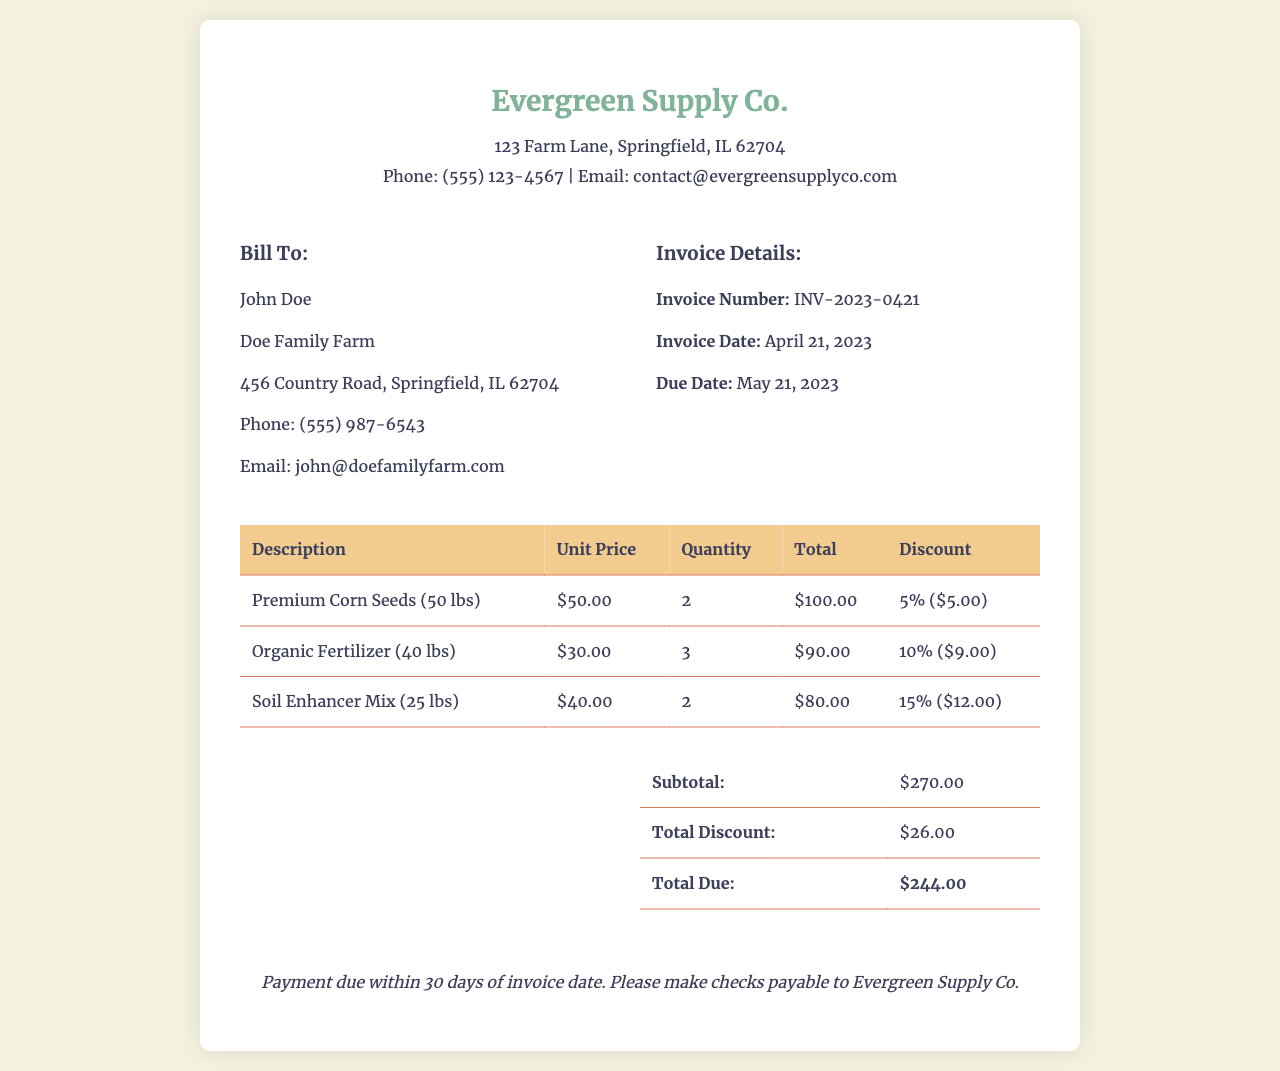What is the invoice number? The invoice number is clearly stated in the document under "Invoice Details."
Answer: INV-2023-0421 What is the total due amount? The total due amount is summarized in the final section of the invoice.
Answer: $244.00 How many bags of Premium Corn Seeds were purchased? The quantity of Premium Corn Seeds is listed in the itemized table under "Quantity."
Answer: 2 What percentage discount was applied to Organic Fertilizer? The discount for Organic Fertilizer is noted in the itemized table.
Answer: 10% When is the payment due? The payment due date is mentioned in the "Invoice Details" section.
Answer: May 21, 2023 What is the total discount given? The total discount is summarized in the final table of the invoice.
Answer: $26.00 Who is the billing address for this invoice? The billing address is provided under "Bill To" in the document.
Answer: Doe Family Farm What is the unit price of Soil Enhancer Mix? The unit price is displayed in the itemized table next to Soil Enhancer Mix.
Answer: $40.00 How much Organic Fertilizer was bought? The quantity of Organic Fertilizer is shown in the itemized table.
Answer: 3 